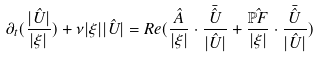<formula> <loc_0><loc_0><loc_500><loc_500>\partial _ { t } ( \frac { | \hat { U } | } { | \xi | } ) + \nu | \xi | | \hat { U } | = R e ( \frac { \hat { A } } { | \xi | } \cdot \frac { \bar { \hat { U } } } { | \hat { U } | } + \frac { \hat { \mathbb { P } F } } { | \xi | } \cdot \frac { \bar { \hat { U } } } { | \hat { U } | } )</formula> 